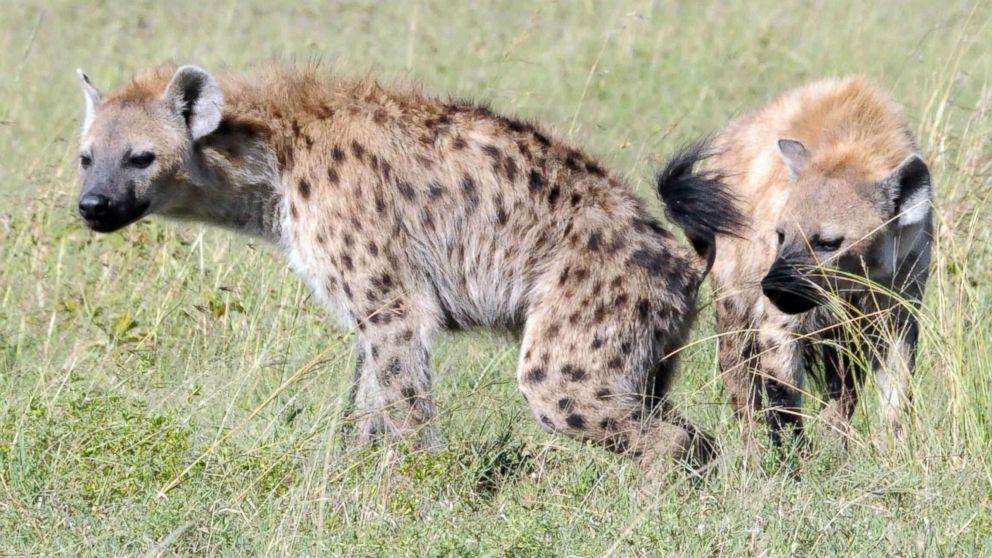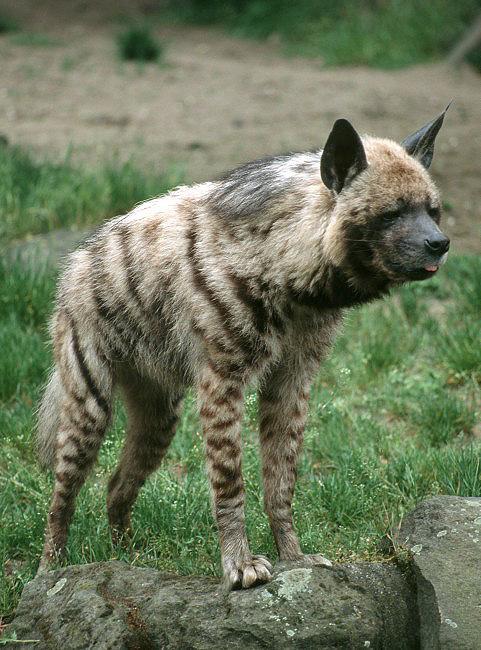The first image is the image on the left, the second image is the image on the right. For the images displayed, is the sentence "An image shows a wild dog with its meal of prey." factually correct? Answer yes or no. No. The first image is the image on the left, the second image is the image on the right. Assess this claim about the two images: "there are at least two hyenas in the image on the left". Correct or not? Answer yes or no. Yes. 